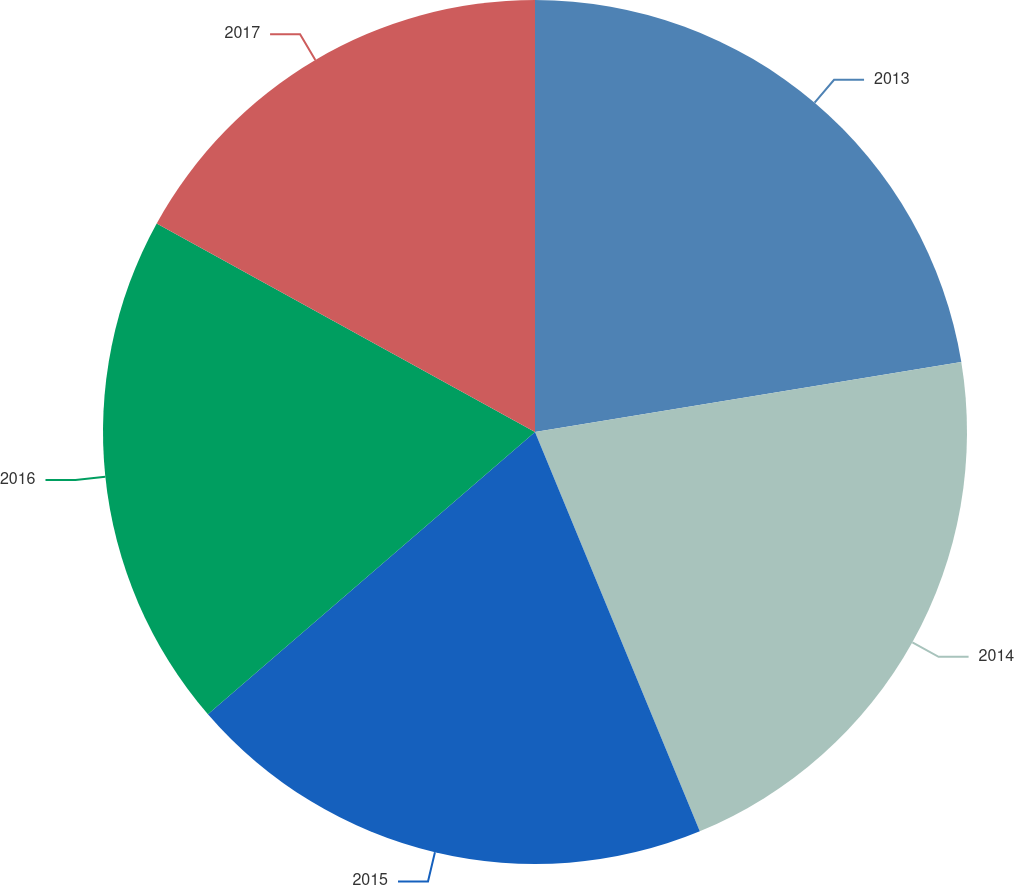Convert chart. <chart><loc_0><loc_0><loc_500><loc_500><pie_chart><fcel>2013<fcel>2014<fcel>2015<fcel>2016<fcel>2017<nl><fcel>22.41%<fcel>21.36%<fcel>19.9%<fcel>19.35%<fcel>16.98%<nl></chart> 